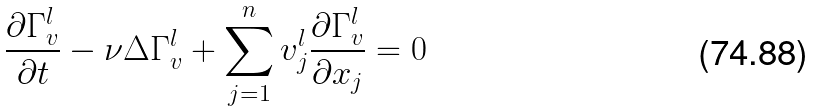<formula> <loc_0><loc_0><loc_500><loc_500>\frac { \partial \Gamma ^ { l } _ { v } } { \partial t } - \nu \Delta \Gamma ^ { l } _ { v } + \sum _ { j = 1 } ^ { n } v ^ { l } _ { j } \frac { \partial \Gamma ^ { l } _ { v } } { \partial x _ { j } } = 0</formula> 